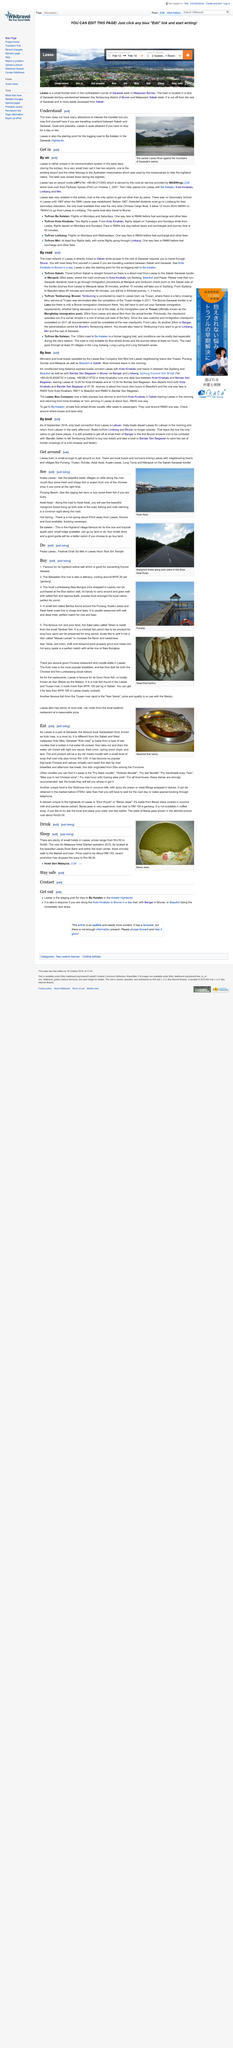Mention a couple of crucial points in this snapshot. Ba Kelalan, a village located in the Sarawak Highlands, is a place that many people are curious about. In Punang Beach, visitors can marvel at the sight of the caging fish farm. Lawas is a quiet, peaceful destination that serves as the starting point for the logging road to Ba Kelalan. It is known for its serene atmosphere and lack of tourist activity. The town lacks numerous attractions that would appeal to travelers and hold their interest. The hot spring is approximately 67 kilometers away from Lawas. 